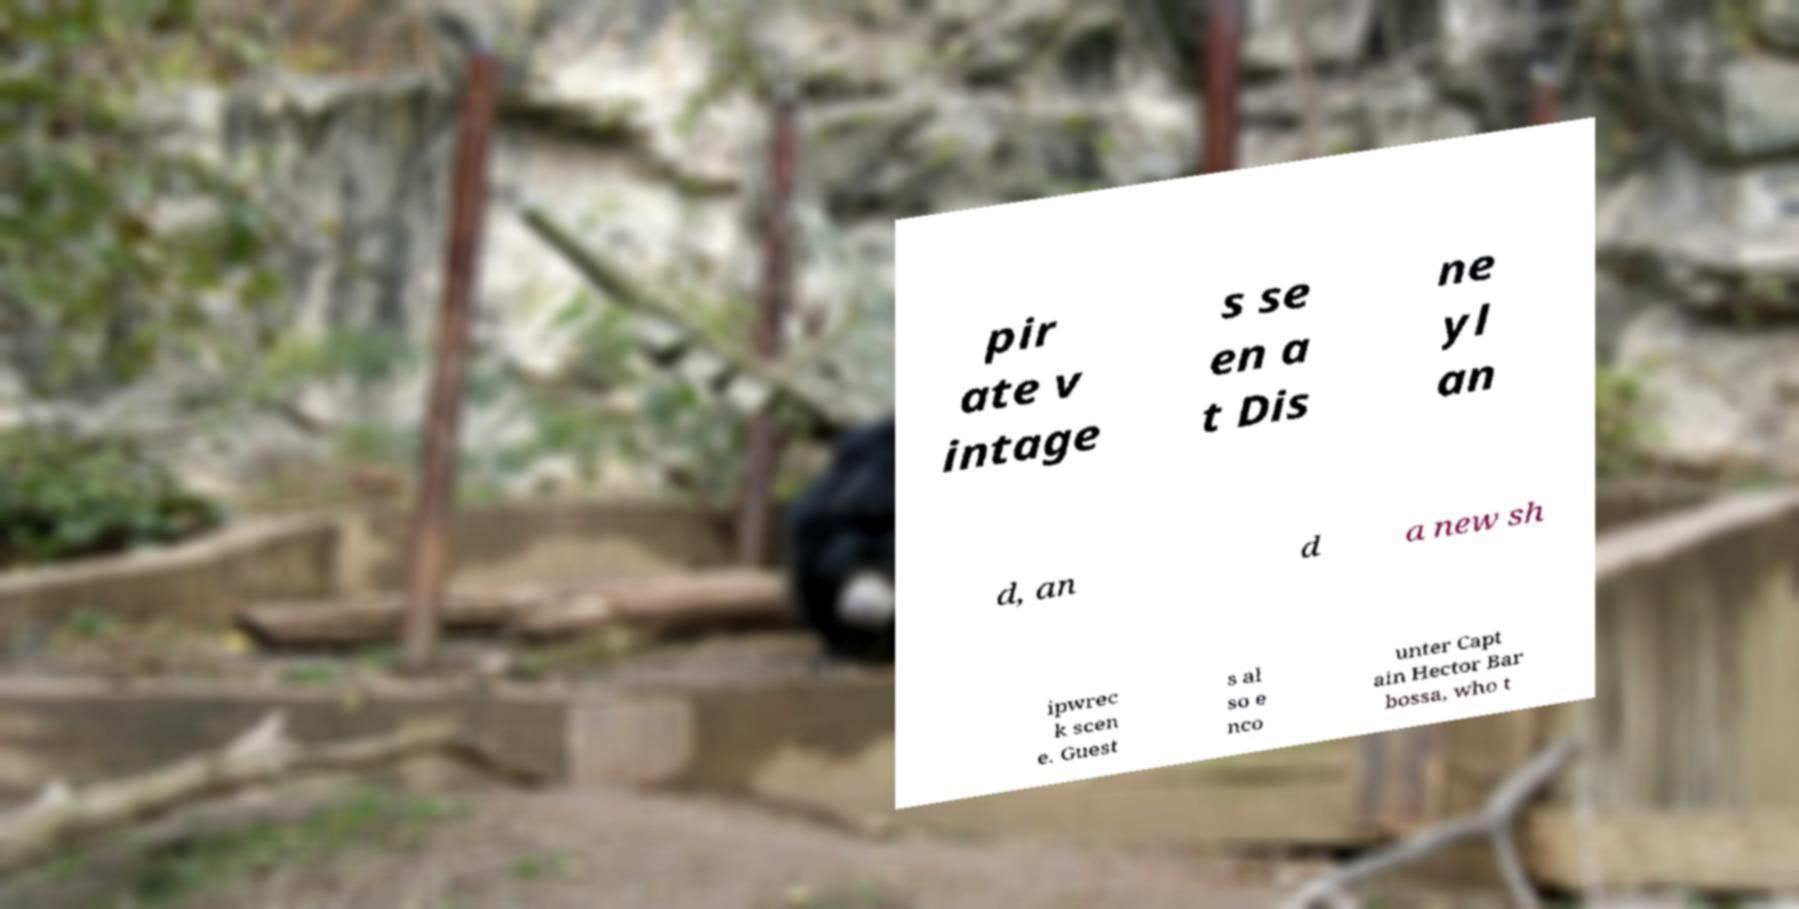Please read and relay the text visible in this image. What does it say? pir ate v intage s se en a t Dis ne yl an d, an d a new sh ipwrec k scen e. Guest s al so e nco unter Capt ain Hector Bar bossa, who t 